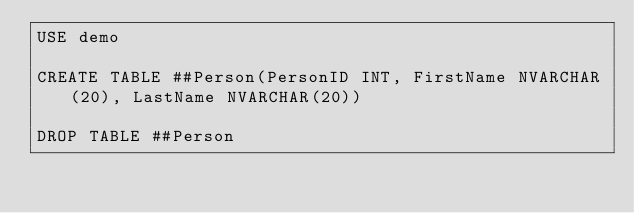Convert code to text. <code><loc_0><loc_0><loc_500><loc_500><_SQL_>USE demo

CREATE TABLE ##Person(PersonID INT, FirstName NVARCHAR(20), LastName NVARCHAR(20))

DROP TABLE ##Person</code> 